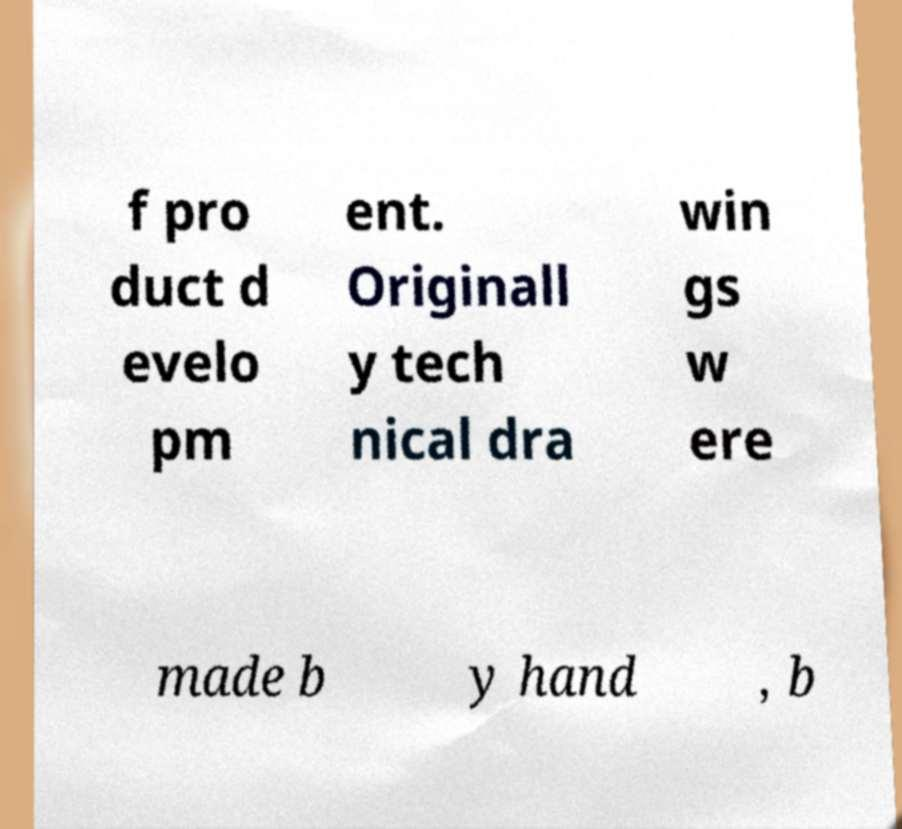Please identify and transcribe the text found in this image. f pro duct d evelo pm ent. Originall y tech nical dra win gs w ere made b y hand , b 